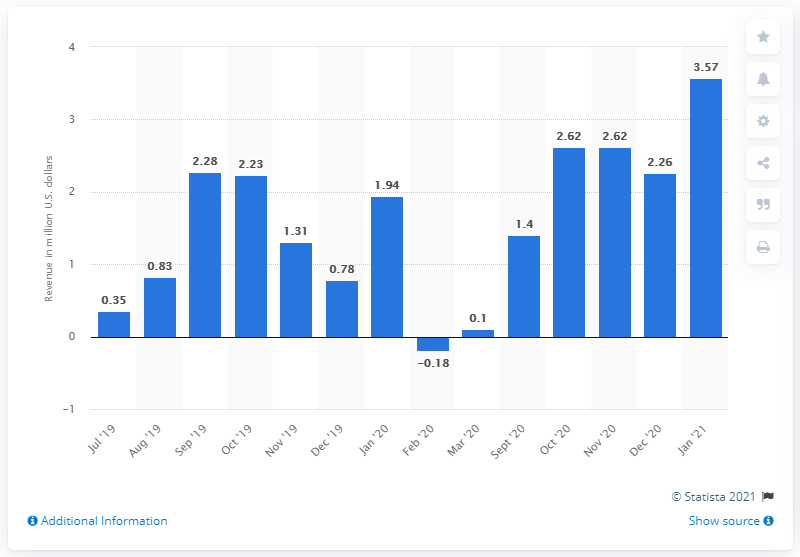List a handful of essential elements in this visual. In January 2021, the state of New York generated approximately $3.57 million in revenue from sports betting. 